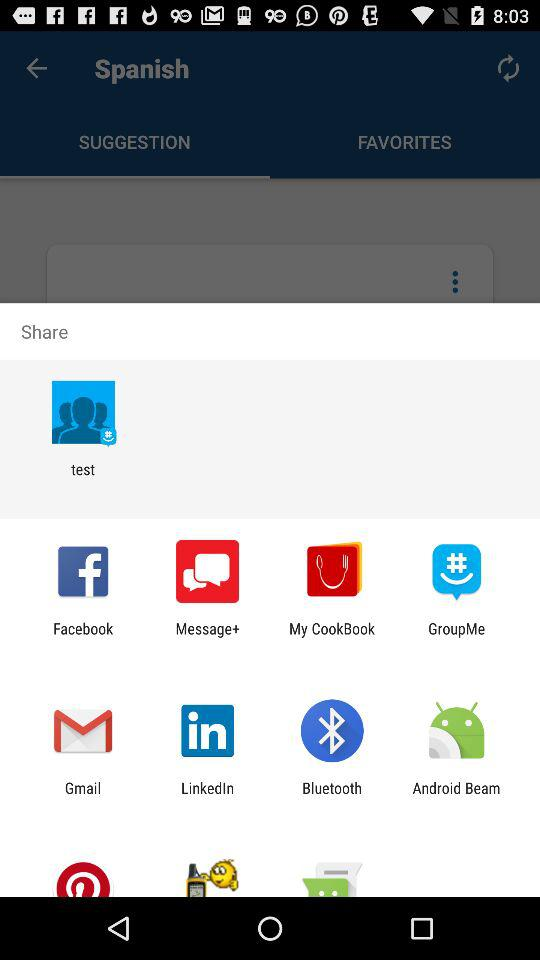What application can I use to share? You can use "Facebook", "Message+", "My CookBook", "GroupMe", "Gmail", "LinkedIn", "Bluetooth" and "Android Beam" to share. 